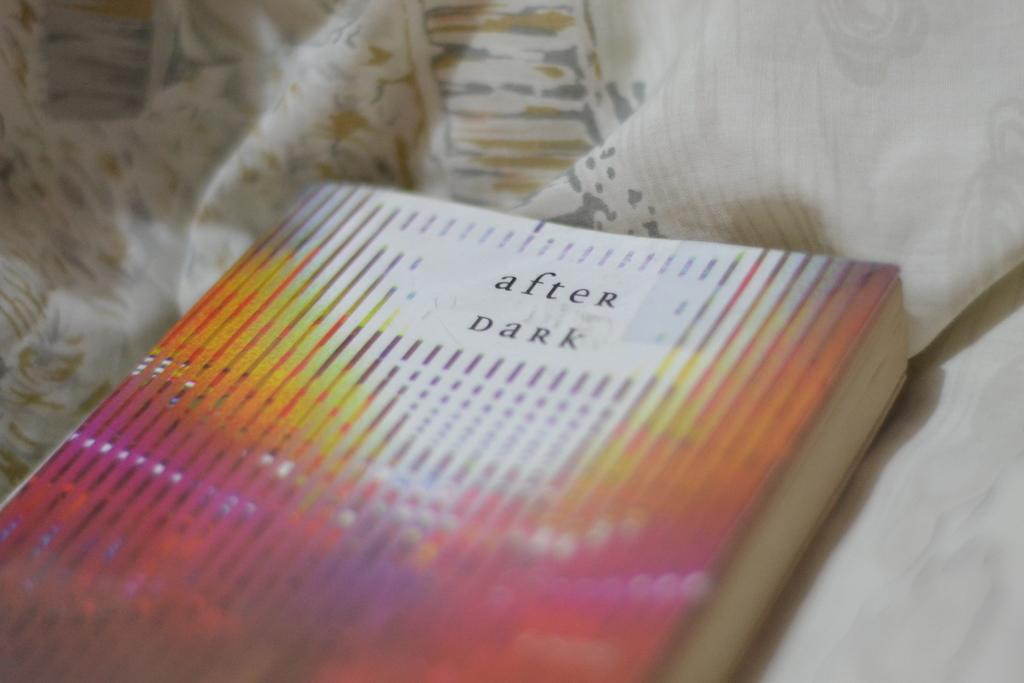<image>
Create a compact narrative representing the image presented. After dark lays closed on top of the bed 